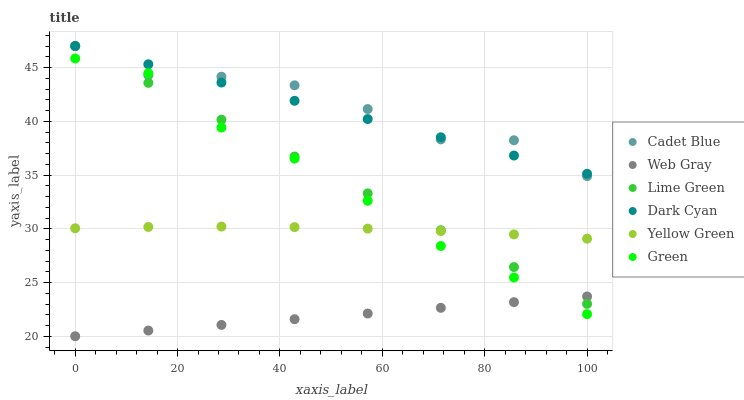Does Web Gray have the minimum area under the curve?
Answer yes or no. Yes. Does Cadet Blue have the maximum area under the curve?
Answer yes or no. Yes. Does Yellow Green have the minimum area under the curve?
Answer yes or no. No. Does Yellow Green have the maximum area under the curve?
Answer yes or no. No. Is Dark Cyan the smoothest?
Answer yes or no. Yes. Is Cadet Blue the roughest?
Answer yes or no. Yes. Is Yellow Green the smoothest?
Answer yes or no. No. Is Yellow Green the roughest?
Answer yes or no. No. Does Web Gray have the lowest value?
Answer yes or no. Yes. Does Yellow Green have the lowest value?
Answer yes or no. No. Does Lime Green have the highest value?
Answer yes or no. Yes. Does Yellow Green have the highest value?
Answer yes or no. No. Is Web Gray less than Yellow Green?
Answer yes or no. Yes. Is Cadet Blue greater than Yellow Green?
Answer yes or no. Yes. Does Cadet Blue intersect Lime Green?
Answer yes or no. Yes. Is Cadet Blue less than Lime Green?
Answer yes or no. No. Is Cadet Blue greater than Lime Green?
Answer yes or no. No. Does Web Gray intersect Yellow Green?
Answer yes or no. No. 